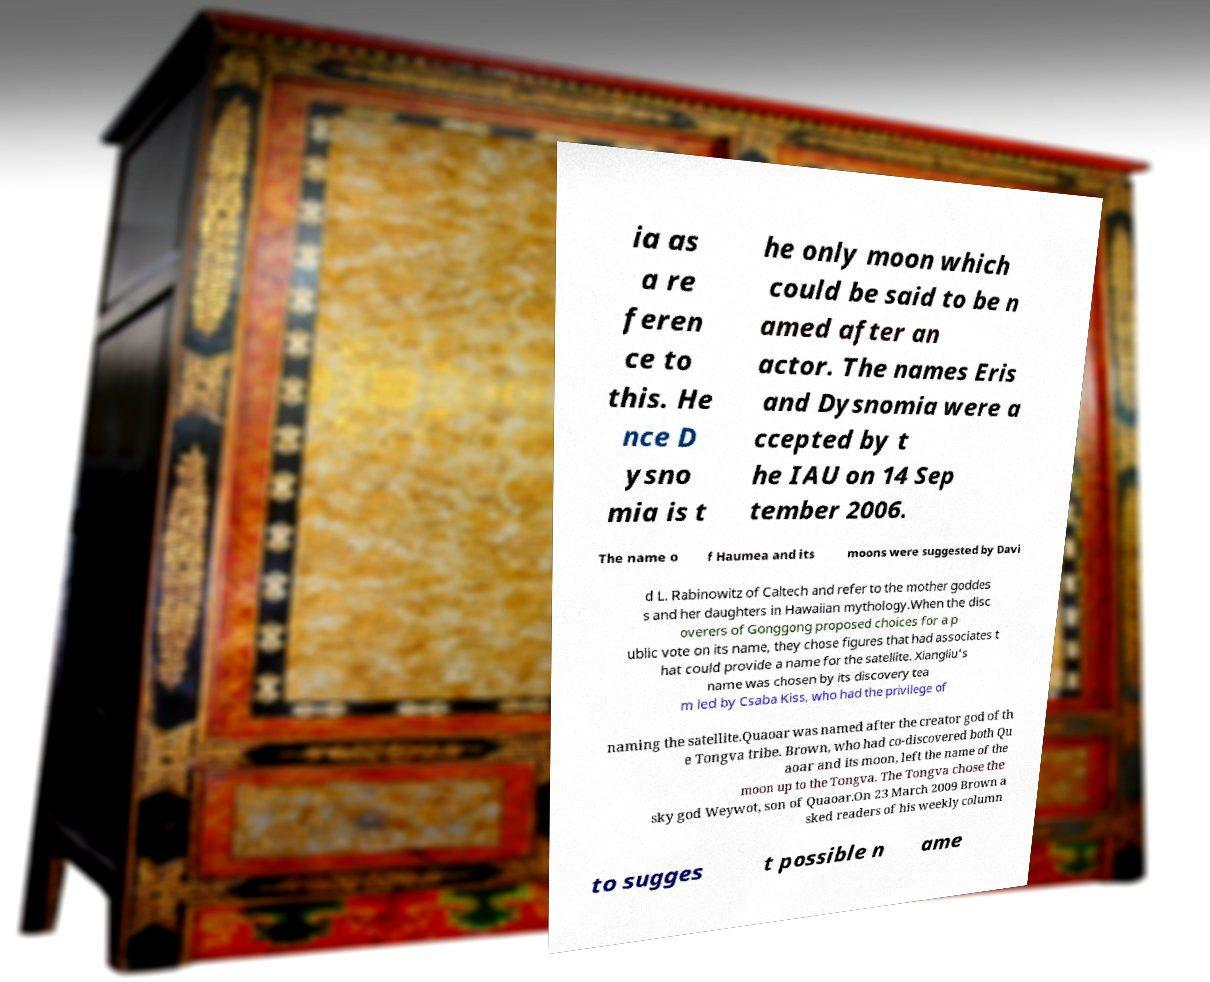I need the written content from this picture converted into text. Can you do that? ia as a re feren ce to this. He nce D ysno mia is t he only moon which could be said to be n amed after an actor. The names Eris and Dysnomia were a ccepted by t he IAU on 14 Sep tember 2006. The name o f Haumea and its moons were suggested by Davi d L. Rabinowitz of Caltech and refer to the mother goddes s and her daughters in Hawaiian mythology.When the disc overers of Gonggong proposed choices for a p ublic vote on its name, they chose figures that had associates t hat could provide a name for the satellite. Xiangliu's name was chosen by its discovery tea m led by Csaba Kiss, who had the privilege of naming the satellite.Quaoar was named after the creator god of th e Tongva tribe. Brown, who had co-discovered both Qu aoar and its moon, left the name of the moon up to the Tongva. The Tongva chose the sky god Weywot, son of Quaoar.On 23 March 2009 Brown a sked readers of his weekly column to sugges t possible n ame 